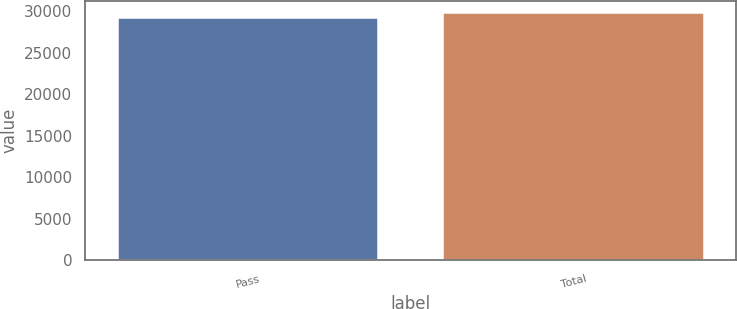Convert chart. <chart><loc_0><loc_0><loc_500><loc_500><bar_chart><fcel>Pass<fcel>Total<nl><fcel>29166<fcel>29754<nl></chart> 